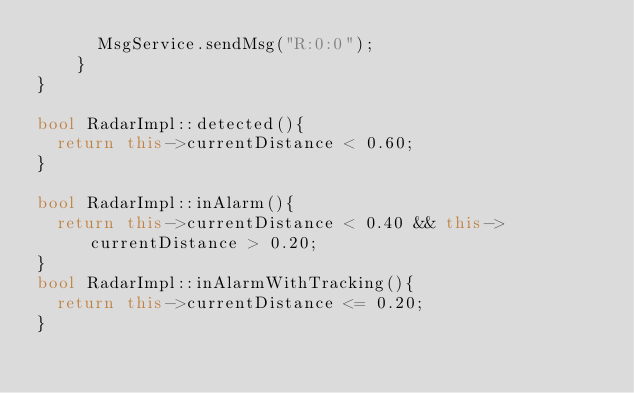<code> <loc_0><loc_0><loc_500><loc_500><_C++_>      MsgService.sendMsg("R:0:0");
    }
}

bool RadarImpl::detected(){
  return this->currentDistance < 0.60;
}

bool RadarImpl::inAlarm(){
  return this->currentDistance < 0.40 && this->currentDistance > 0.20;
}
bool RadarImpl::inAlarmWithTracking(){
  return this->currentDistance <= 0.20;
}
</code> 